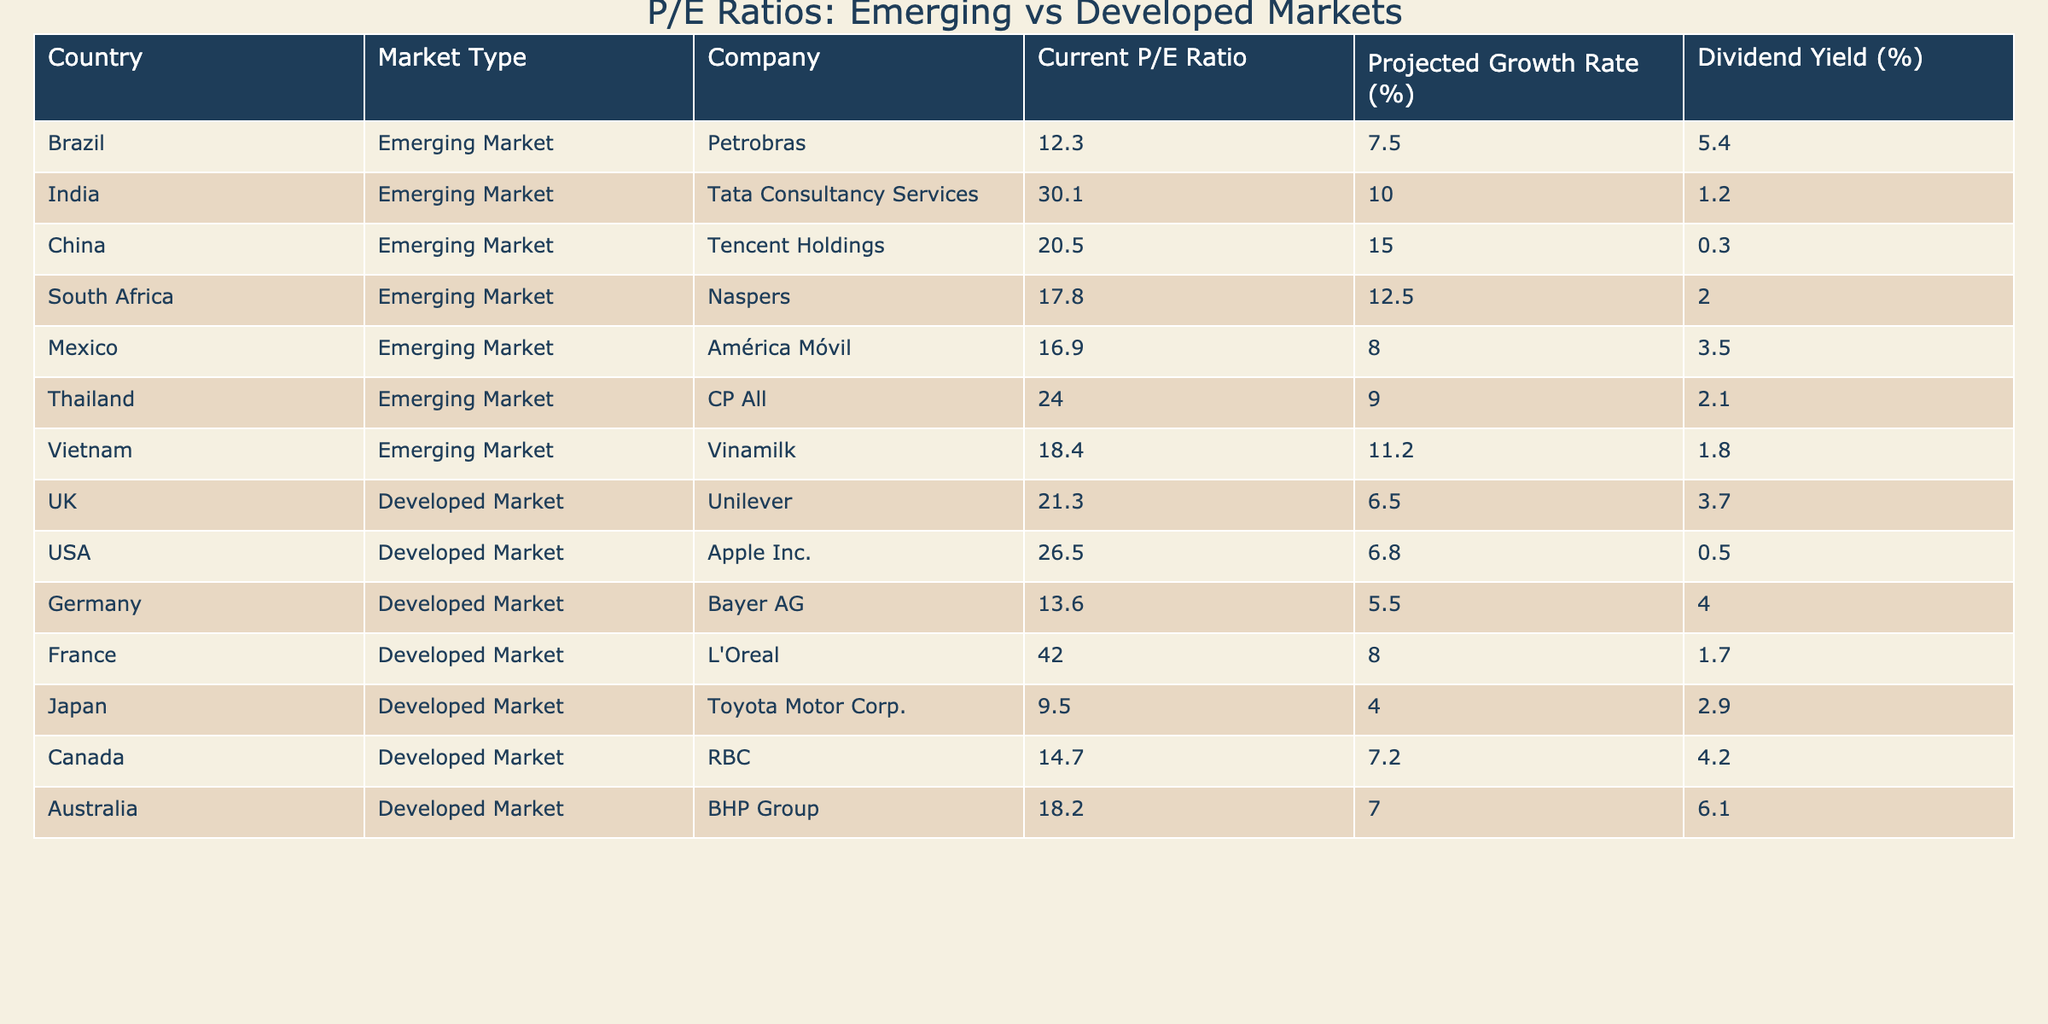What is the P/E ratio of Tencent Holdings? The P/E ratio for Tencent Holdings is listed directly in the table under the "Current P/E Ratio" column for the company in China.
Answer: 20.5 Which company has the highest P/E ratio in the table? By comparing the values in the "Current P/E Ratio" column, we find that L'Oreal from France has the highest value of 42.0.
Answer: L'Oreal What is the average P/E ratio of the emerging market stocks listed? The average is calculated by summing the P/E ratios of all emerging market companies (12.3 + 30.1 + 20.5 + 17.8 + 16.9 + 24.0 + 18.4 = 139.0) and dividing by the number of companies (7). This gives an average of 19.857.
Answer: Approximately 19.9 What is the difference between the highest and lowest P/E ratios among developed market stocks? The highest P/E ratio is for L'Oreal (42.0), and the lowest is for Toyota Motor Corp (9.5). Calculating the difference: 42.0 - 9.5 = 32.5.
Answer: 32.5 Do any companies in the emerging market have a projected growth rate of over 10%? Checking the "Projected Growth Rate (%)" column, Tata Consultancy Services, Tencent Holdings, and Naspers all exceed 10%.
Answer: Yes Which market type has a higher average dividend yield, emerging or developed markets? The average dividend yield for emerging markets is calculated as (5.4 + 1.2 + 0.3 + 2.0 + 3.5 + 2.1 + 1.8) / 7 = 2.3%. The average for developed markets is (3.7 + 0.5 + 4.0 + 1.7 + 2.9 + 4.2 + 6.1) / 7 = 3.0%. Developed markets have a higher average yield.
Answer: Developed markets What is the P/E ratio trend between India and China? The P/E ratio for Tata Consultancy Services from India is 30.1, while Tencent Holdings from China is 20.5. This indicates that India's P/E ratio is higher than China's.
Answer: India's P/E ratio is higher Is there a company from Mexico with a P/E ratio below 20? In the table, América Móvil from Mexico has a P/E ratio of 16.9, which is below 20.
Answer: Yes Which emerging market company has the lowest dividend yield? By examining the "Dividend Yield (%)" column, Tencent Holdings has the lowest yield at 0.3%.
Answer: Tencent Holdings How does the projected growth rate of Apple Inc. compare to that of Petrobras? Apple Inc. has a projected growth rate of 6.8%, while Petrobras has a higher growth rate of 7.5%. Thus, Petrobras has a slightly higher growth rate.
Answer: Petrobras has a higher growth rate 